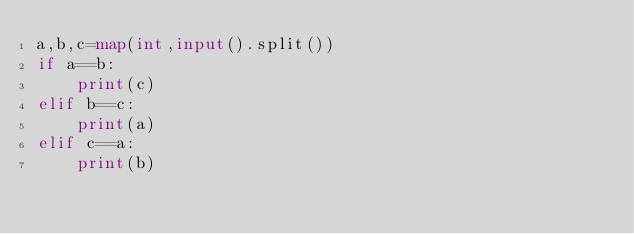Convert code to text. <code><loc_0><loc_0><loc_500><loc_500><_Python_>a,b,c=map(int,input().split())
if a==b:
    print(c)
elif b==c:
    print(a)
elif c==a:
    print(b)
</code> 